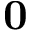<formula> <loc_0><loc_0><loc_500><loc_500>0</formula> 